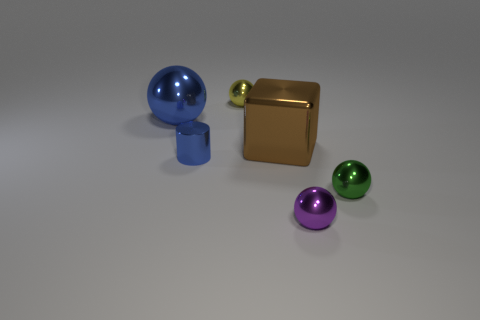What number of other things have the same shape as the tiny purple metallic thing?
Your answer should be very brief. 3. What material is the small ball on the left side of the big brown object?
Your response must be concise. Metal. Is the number of blue cylinders that are in front of the green thing less than the number of tiny purple cubes?
Offer a terse response. No. Is the small purple thing the same shape as the green shiny thing?
Make the answer very short. Yes. Is there anything else that has the same shape as the small green object?
Your answer should be compact. Yes. Are any blue matte cylinders visible?
Make the answer very short. No. There is a purple metal object; does it have the same shape as the metal thing that is behind the large sphere?
Make the answer very short. Yes. The blue thing that is to the right of the big thing that is to the left of the brown thing is made of what material?
Keep it short and to the point. Metal. What color is the tiny shiny cylinder?
Provide a succinct answer. Blue. There is a big object on the left side of the shiny block; does it have the same color as the small object that is to the left of the yellow thing?
Give a very brief answer. Yes. 